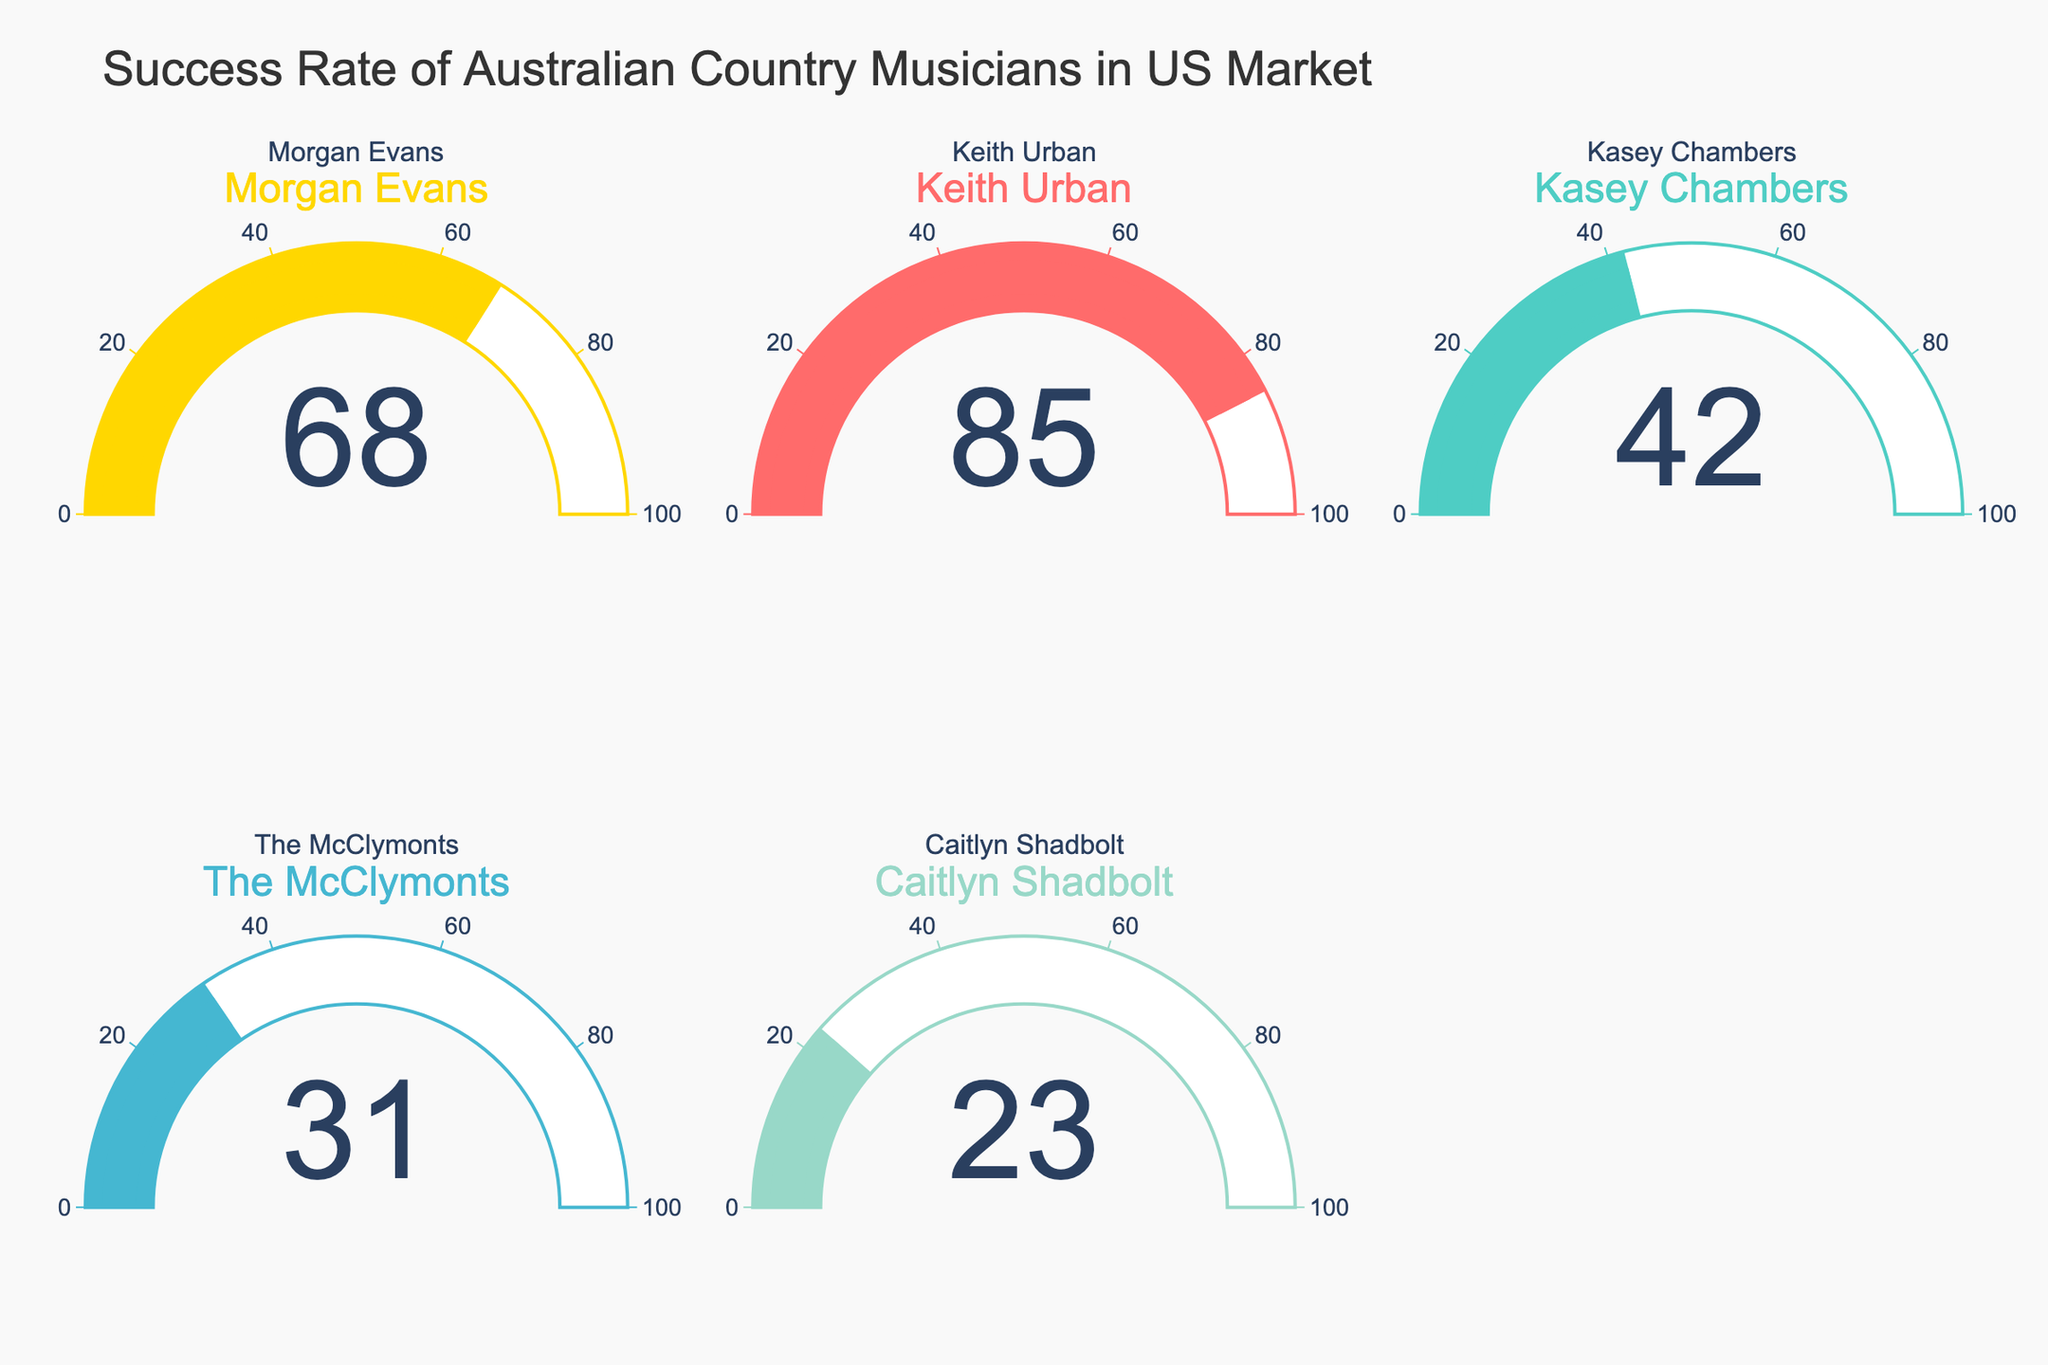What's the success rate of Morgan Evans? Look at the gauge chart for Morgan Evans. The number displayed is the success rate.
Answer: 68 What's the title of the figure? The title is displayed at the top of the figure and summarizes the content of the charts.
Answer: Success Rate of Australian Country Musicians in US Market What's the average success rate of all the artists? To find the average, add the success rates of all the artists (68 + 85 + 42 + 31 + 23) and divide by the number of artists (5).
Answer: 49.8 Which artist has the highest success rate? Compare the success rates displayed on each gauge chart. The highest number is the highest success rate.
Answer: Keith Urban Which artist has the lowest success rate? Compare the success rates displayed on each gauge chart. The lowest number is the lowest success rate.
Answer: Caitlyn Shadbolt How much higher is Keith Urban's success rate compared to The McClymonts'? Subtract The McClymonts' success rate from Keith Urban's success rate (85 - 31).
Answer: 54 What is the range of success rates represented in the figure? Identify the highest and lowest success rates displayed on the gauge charts, then subtract the lowest from the highest (85 - 23).
Answer: 62 What percentage of the maximum possible success rate did Kasey Chambers achieve? Divide Kasey Chambers' success rate by the maximum possible rate (100) and multiply by 100 (42/100 * 100).
Answer: 42% Which artist's success rate is closest to 50%? Identify the success rate that is nearest to 50% by comparing the difference of each rate from 50 (abs(68-50), abs(85-50), abs(42-50), abs(31-50), abs(23-50)).
Answer: Kasey Chambers 